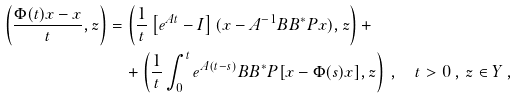<formula> <loc_0><loc_0><loc_500><loc_500>\left ( \frac { \Phi ( t ) x - x } { t } , z \right ) & = \left ( \frac { 1 } { t } \left [ e ^ { A t } - I \right ] ( x - A ^ { - 1 } B B ^ { * } P x ) , z \right ) + \\ & \quad + \left ( \frac { 1 } { t } \int _ { 0 } ^ { t } e ^ { A ( t - s ) } B B ^ { * } P [ x - \Phi ( s ) x ] , z \right ) \, , \quad t > 0 \, , \, z \in Y \, ,</formula> 